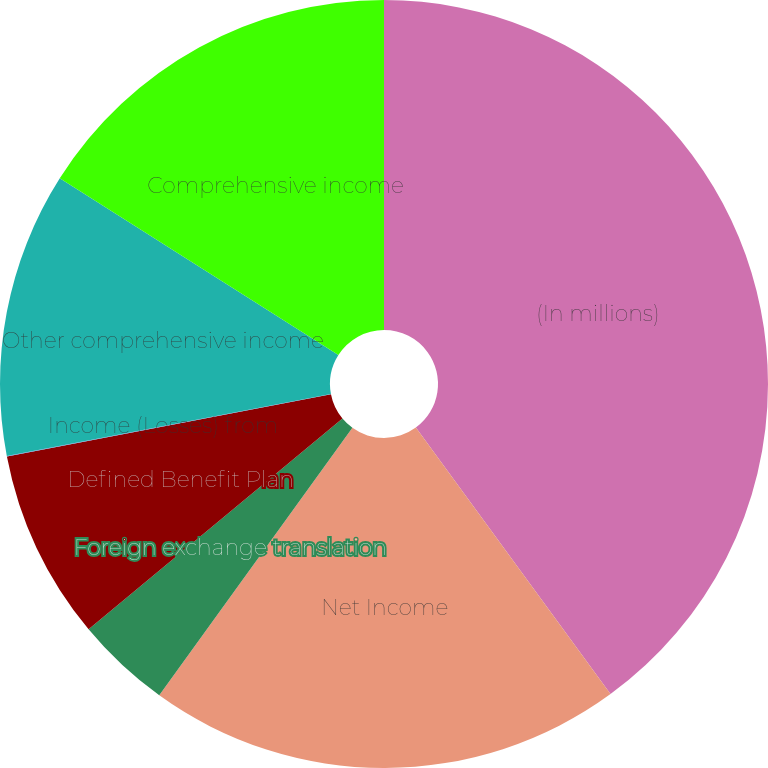<chart> <loc_0><loc_0><loc_500><loc_500><pie_chart><fcel>(In millions)<fcel>Net Income<fcel>Foreign exchange translation<fcel>Defined Benefit Plan<fcel>Income (Losses) from<fcel>Other comprehensive income<fcel>Comprehensive income<nl><fcel>39.96%<fcel>19.99%<fcel>4.02%<fcel>8.01%<fcel>0.02%<fcel>12.0%<fcel>16.0%<nl></chart> 